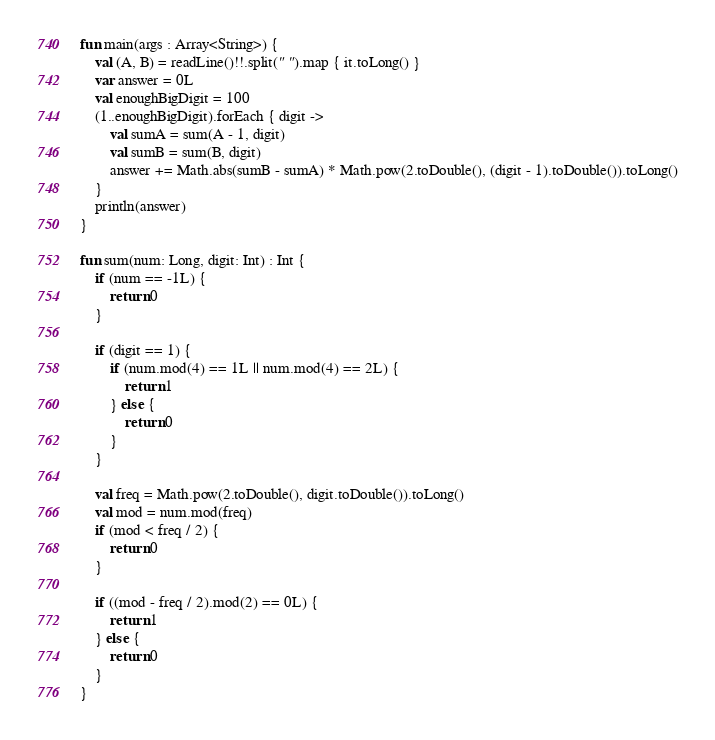Convert code to text. <code><loc_0><loc_0><loc_500><loc_500><_Kotlin_>fun main(args : Array<String>) {
    val (A, B) = readLine()!!.split(" ").map { it.toLong() }
    var answer = 0L
    val enoughBigDigit = 100
    (1..enoughBigDigit).forEach { digit ->
        val sumA = sum(A - 1, digit)
        val sumB = sum(B, digit)
        answer += Math.abs(sumB - sumA) * Math.pow(2.toDouble(), (digit - 1).toDouble()).toLong()
    }
    println(answer)
}

fun sum(num: Long, digit: Int) : Int {
    if (num == -1L) {
        return 0
    }

    if (digit == 1) {
        if (num.mod(4) == 1L || num.mod(4) == 2L) {
            return 1
        } else {
            return 0
        }
    }

    val freq = Math.pow(2.toDouble(), digit.toDouble()).toLong()
    val mod = num.mod(freq)
    if (mod < freq / 2) {
        return 0
    }

    if ((mod - freq / 2).mod(2) == 0L) {
        return 1
    } else {
        return 0
    }
}</code> 